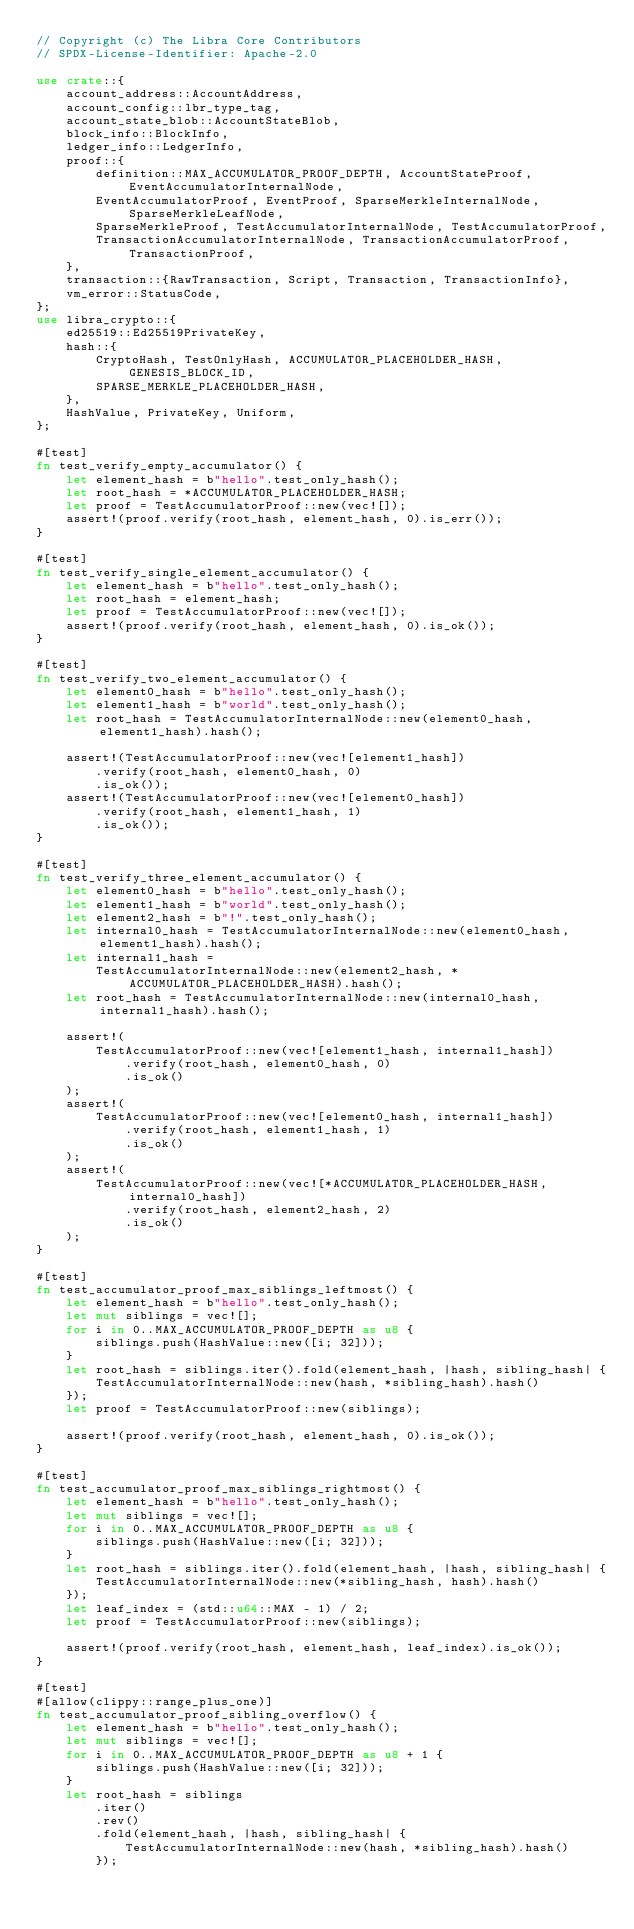<code> <loc_0><loc_0><loc_500><loc_500><_Rust_>// Copyright (c) The Libra Core Contributors
// SPDX-License-Identifier: Apache-2.0

use crate::{
    account_address::AccountAddress,
    account_config::lbr_type_tag,
    account_state_blob::AccountStateBlob,
    block_info::BlockInfo,
    ledger_info::LedgerInfo,
    proof::{
        definition::MAX_ACCUMULATOR_PROOF_DEPTH, AccountStateProof, EventAccumulatorInternalNode,
        EventAccumulatorProof, EventProof, SparseMerkleInternalNode, SparseMerkleLeafNode,
        SparseMerkleProof, TestAccumulatorInternalNode, TestAccumulatorProof,
        TransactionAccumulatorInternalNode, TransactionAccumulatorProof, TransactionProof,
    },
    transaction::{RawTransaction, Script, Transaction, TransactionInfo},
    vm_error::StatusCode,
};
use libra_crypto::{
    ed25519::Ed25519PrivateKey,
    hash::{
        CryptoHash, TestOnlyHash, ACCUMULATOR_PLACEHOLDER_HASH, GENESIS_BLOCK_ID,
        SPARSE_MERKLE_PLACEHOLDER_HASH,
    },
    HashValue, PrivateKey, Uniform,
};

#[test]
fn test_verify_empty_accumulator() {
    let element_hash = b"hello".test_only_hash();
    let root_hash = *ACCUMULATOR_PLACEHOLDER_HASH;
    let proof = TestAccumulatorProof::new(vec![]);
    assert!(proof.verify(root_hash, element_hash, 0).is_err());
}

#[test]
fn test_verify_single_element_accumulator() {
    let element_hash = b"hello".test_only_hash();
    let root_hash = element_hash;
    let proof = TestAccumulatorProof::new(vec![]);
    assert!(proof.verify(root_hash, element_hash, 0).is_ok());
}

#[test]
fn test_verify_two_element_accumulator() {
    let element0_hash = b"hello".test_only_hash();
    let element1_hash = b"world".test_only_hash();
    let root_hash = TestAccumulatorInternalNode::new(element0_hash, element1_hash).hash();

    assert!(TestAccumulatorProof::new(vec![element1_hash])
        .verify(root_hash, element0_hash, 0)
        .is_ok());
    assert!(TestAccumulatorProof::new(vec![element0_hash])
        .verify(root_hash, element1_hash, 1)
        .is_ok());
}

#[test]
fn test_verify_three_element_accumulator() {
    let element0_hash = b"hello".test_only_hash();
    let element1_hash = b"world".test_only_hash();
    let element2_hash = b"!".test_only_hash();
    let internal0_hash = TestAccumulatorInternalNode::new(element0_hash, element1_hash).hash();
    let internal1_hash =
        TestAccumulatorInternalNode::new(element2_hash, *ACCUMULATOR_PLACEHOLDER_HASH).hash();
    let root_hash = TestAccumulatorInternalNode::new(internal0_hash, internal1_hash).hash();

    assert!(
        TestAccumulatorProof::new(vec![element1_hash, internal1_hash])
            .verify(root_hash, element0_hash, 0)
            .is_ok()
    );
    assert!(
        TestAccumulatorProof::new(vec![element0_hash, internal1_hash])
            .verify(root_hash, element1_hash, 1)
            .is_ok()
    );
    assert!(
        TestAccumulatorProof::new(vec![*ACCUMULATOR_PLACEHOLDER_HASH, internal0_hash])
            .verify(root_hash, element2_hash, 2)
            .is_ok()
    );
}

#[test]
fn test_accumulator_proof_max_siblings_leftmost() {
    let element_hash = b"hello".test_only_hash();
    let mut siblings = vec![];
    for i in 0..MAX_ACCUMULATOR_PROOF_DEPTH as u8 {
        siblings.push(HashValue::new([i; 32]));
    }
    let root_hash = siblings.iter().fold(element_hash, |hash, sibling_hash| {
        TestAccumulatorInternalNode::new(hash, *sibling_hash).hash()
    });
    let proof = TestAccumulatorProof::new(siblings);

    assert!(proof.verify(root_hash, element_hash, 0).is_ok());
}

#[test]
fn test_accumulator_proof_max_siblings_rightmost() {
    let element_hash = b"hello".test_only_hash();
    let mut siblings = vec![];
    for i in 0..MAX_ACCUMULATOR_PROOF_DEPTH as u8 {
        siblings.push(HashValue::new([i; 32]));
    }
    let root_hash = siblings.iter().fold(element_hash, |hash, sibling_hash| {
        TestAccumulatorInternalNode::new(*sibling_hash, hash).hash()
    });
    let leaf_index = (std::u64::MAX - 1) / 2;
    let proof = TestAccumulatorProof::new(siblings);

    assert!(proof.verify(root_hash, element_hash, leaf_index).is_ok());
}

#[test]
#[allow(clippy::range_plus_one)]
fn test_accumulator_proof_sibling_overflow() {
    let element_hash = b"hello".test_only_hash();
    let mut siblings = vec![];
    for i in 0..MAX_ACCUMULATOR_PROOF_DEPTH as u8 + 1 {
        siblings.push(HashValue::new([i; 32]));
    }
    let root_hash = siblings
        .iter()
        .rev()
        .fold(element_hash, |hash, sibling_hash| {
            TestAccumulatorInternalNode::new(hash, *sibling_hash).hash()
        });</code> 